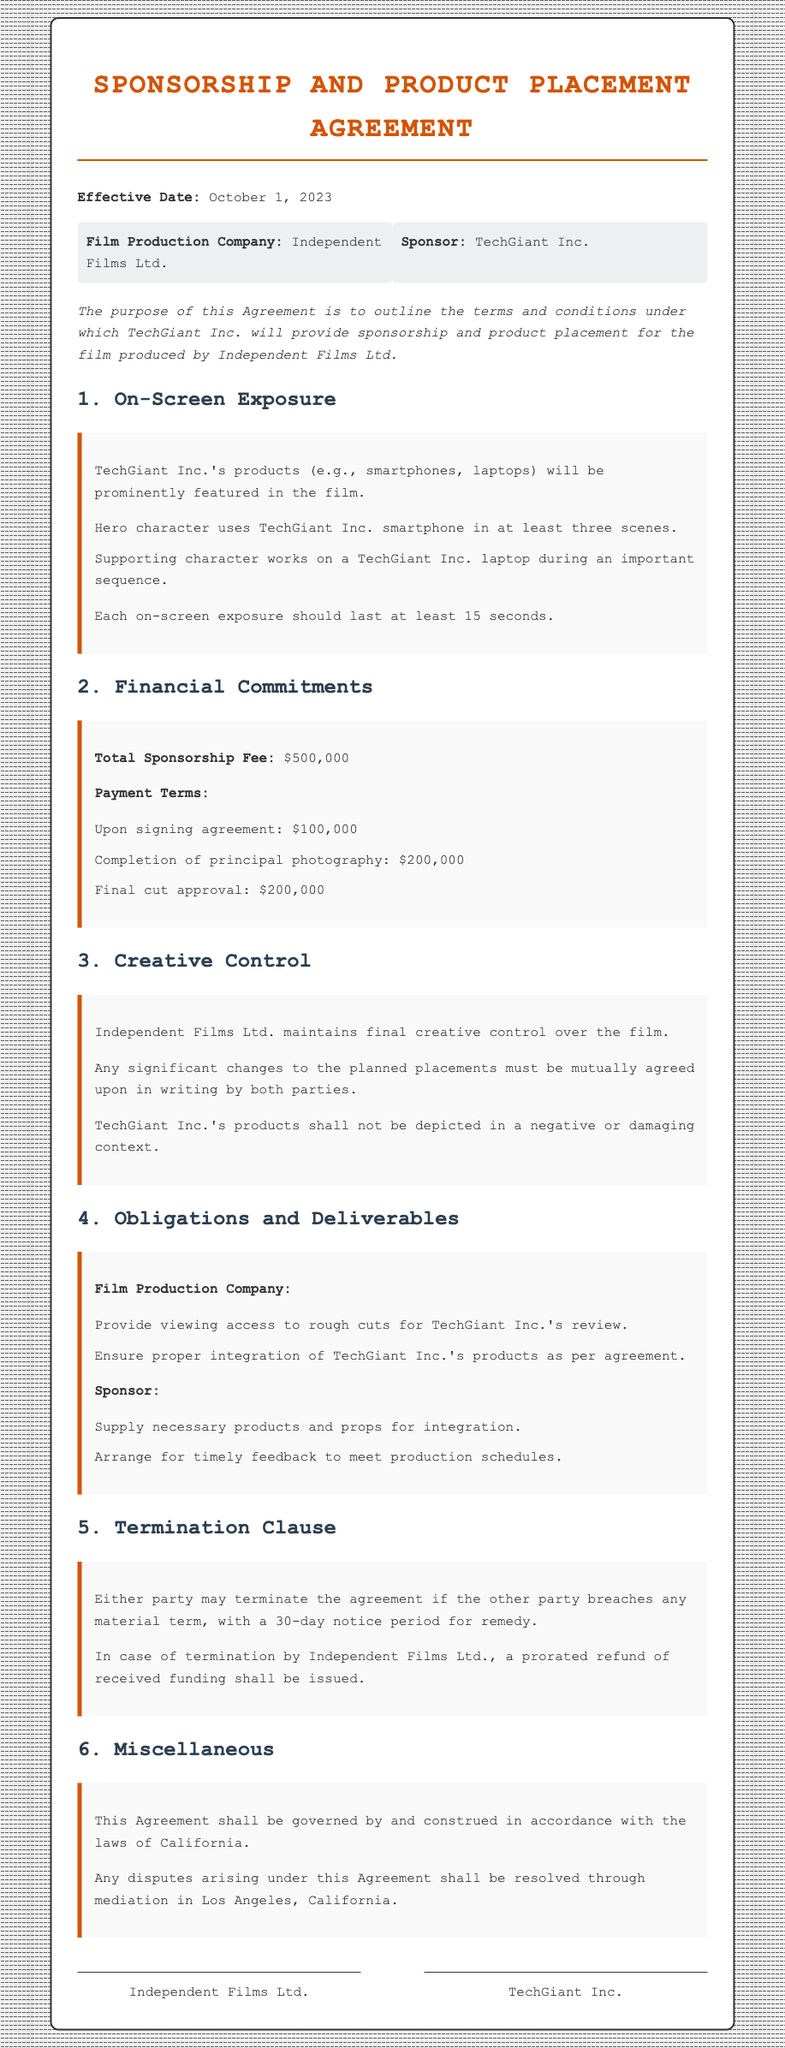what is the effective date of the agreement? The effective date is explicitly mentioned in the document, which is October 1, 2023.
Answer: October 1, 2023 who is the sponsor? The document states that the sponsor is TechGiant Inc.
Answer: TechGiant Inc what is the total sponsorship fee? The total sponsorship fee is listed in the financial commitments section, which states the amount is $500,000.
Answer: $500,000 how many scenes feature the hero character using the smartphone? The document specifies that the hero character will use the smartphone in at least three scenes.
Answer: three scenes what must be agreed upon in writing for significant changes? The document indicates that any significant changes to the planned placements must be mutually agreed upon in writing by both parties.
Answer: mutually agreed upon in writing what is the notice period for remedy in the termination clause? The termination clause states that a 30-day notice period is required for remedy in case of a breach of any material term.
Answer: 30-day notice period where will disputes be resolved? The document specifies that any disputes arising under this agreement shall be resolved through mediation in Los Angeles, California.
Answer: Los Angeles, California what does Independent Films Ltd. provide to TechGiant Inc. during production? The obligations state that Independent Films Ltd. must provide viewing access to rough cuts for TechGiant Inc.'s review.
Answer: viewing access to rough cuts what kind of products are to be integrated into the film? The document mentions that TechGiant Inc.'s products, specifically smartphones and laptops, will be prominently featured in the film.
Answer: smartphones and laptops 